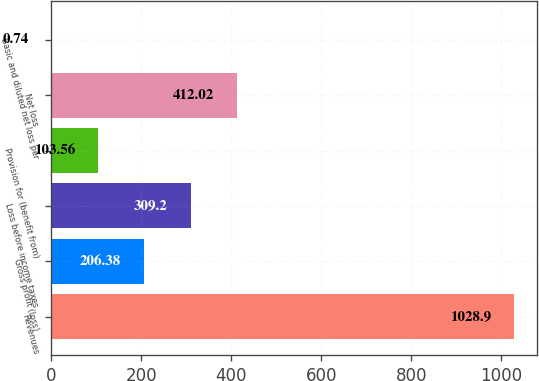Convert chart to OTSL. <chart><loc_0><loc_0><loc_500><loc_500><bar_chart><fcel>Revenues<fcel>Gross profit (loss)<fcel>Loss before income taxes<fcel>Provision for (benefit from)<fcel>Net loss<fcel>Basic and diluted net loss per<nl><fcel>1028.9<fcel>206.38<fcel>309.2<fcel>103.56<fcel>412.02<fcel>0.74<nl></chart> 